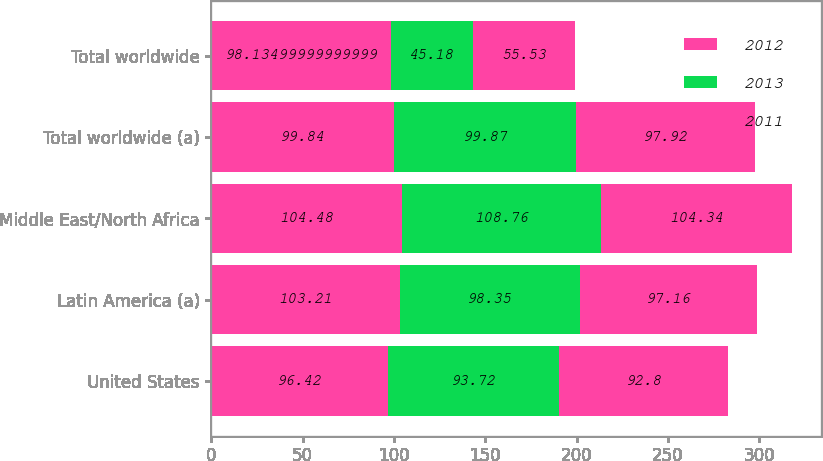Convert chart. <chart><loc_0><loc_0><loc_500><loc_500><stacked_bar_chart><ecel><fcel>United States<fcel>Latin America (a)<fcel>Middle East/North Africa<fcel>Total worldwide (a)<fcel>Total worldwide<nl><fcel>2012<fcel>96.42<fcel>103.21<fcel>104.48<fcel>99.84<fcel>98.135<nl><fcel>2013<fcel>93.72<fcel>98.35<fcel>108.76<fcel>99.87<fcel>45.18<nl><fcel>2011<fcel>92.8<fcel>97.16<fcel>104.34<fcel>97.92<fcel>55.53<nl></chart> 